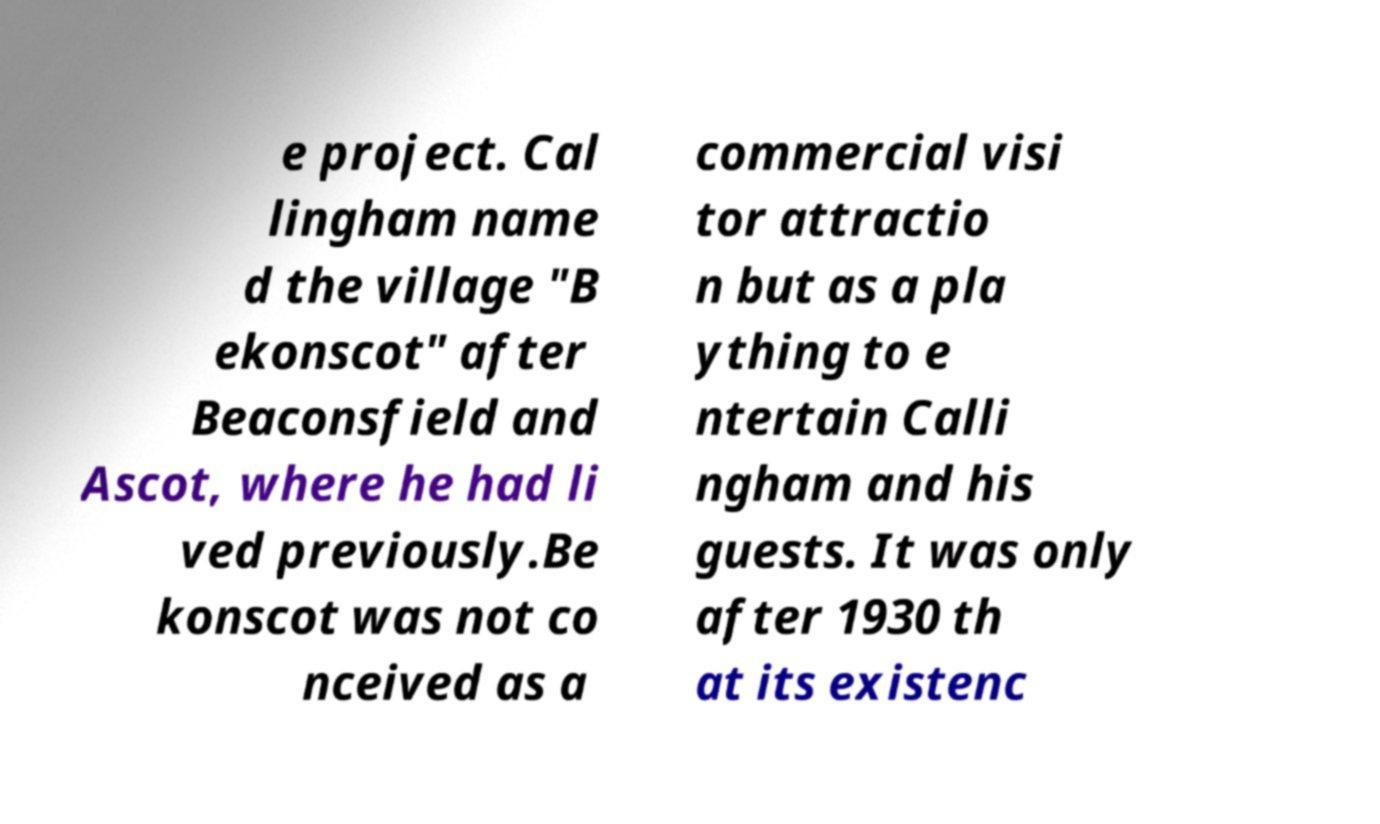Please identify and transcribe the text found in this image. e project. Cal lingham name d the village "B ekonscot" after Beaconsfield and Ascot, where he had li ved previously.Be konscot was not co nceived as a commercial visi tor attractio n but as a pla ything to e ntertain Calli ngham and his guests. It was only after 1930 th at its existenc 